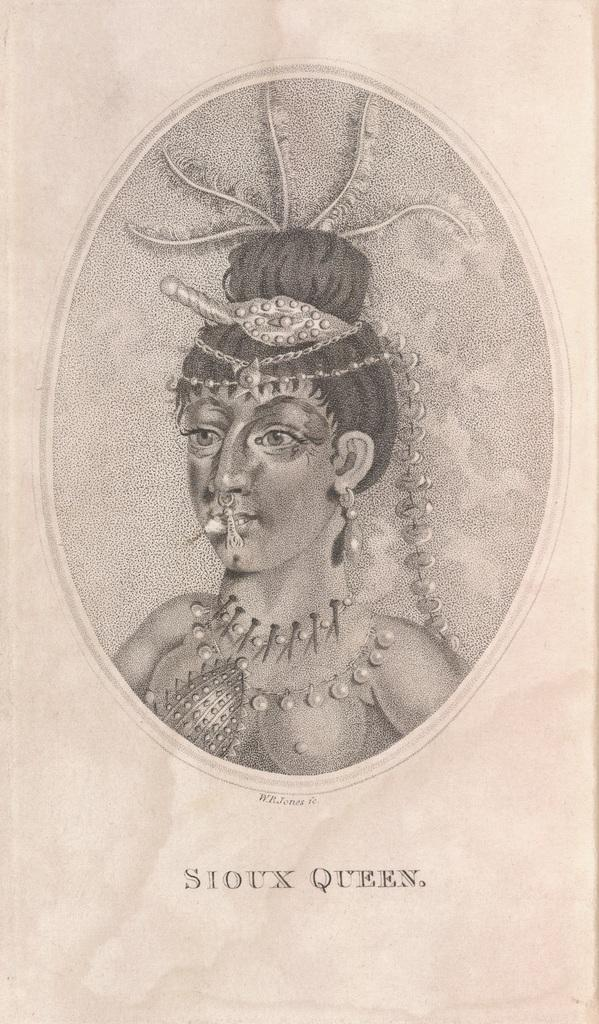What is the main subject of the image? There is a person in the image. What is the color scheme of the image? The image is black and white. What type of note is being discussed in the image? There is no note or discussion present in the image; it only features a person. What type of operation is being performed in the image? There is no operation or procedure being performed in the image; it only features a person. 